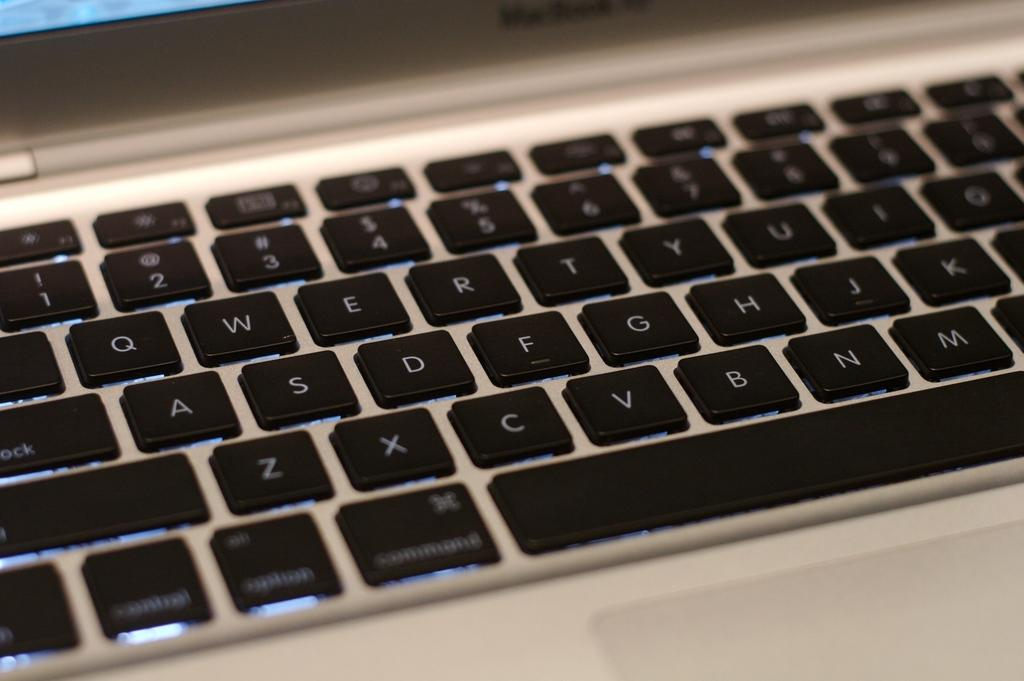<image>
Give a short and clear explanation of the subsequent image. A computer keyboard displaying the letters of the alphabet including A, S, D, F, and G 